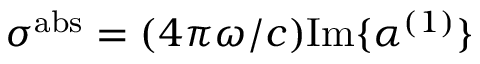Convert formula to latex. <formula><loc_0><loc_0><loc_500><loc_500>\sigma ^ { a b s } = ( 4 \pi \omega / c ) I m \{ \alpha ^ { ( 1 ) } \}</formula> 